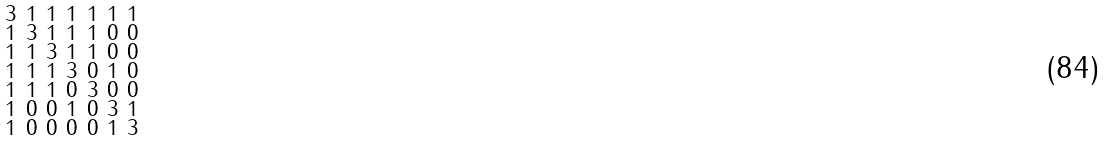<formula> <loc_0><loc_0><loc_500><loc_500>\begin{smallmatrix} 3 & 1 & 1 & 1 & 1 & 1 & 1 \\ 1 & 3 & 1 & 1 & 1 & 0 & 0 \\ 1 & 1 & 3 & 1 & 1 & 0 & 0 \\ 1 & 1 & 1 & 3 & 0 & 1 & 0 \\ 1 & 1 & 1 & 0 & 3 & 0 & 0 \\ 1 & 0 & 0 & 1 & 0 & 3 & 1 \\ 1 & 0 & 0 & 0 & 0 & 1 & 3 \end{smallmatrix}</formula> 